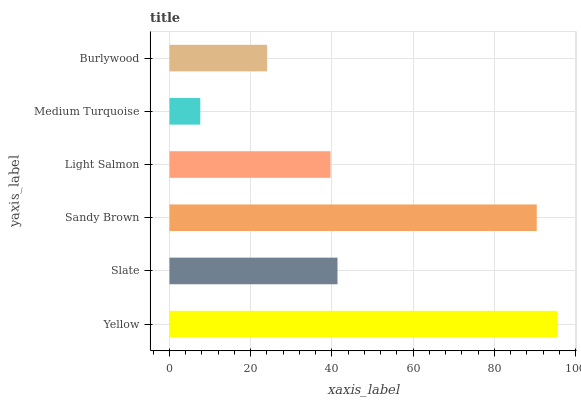Is Medium Turquoise the minimum?
Answer yes or no. Yes. Is Yellow the maximum?
Answer yes or no. Yes. Is Slate the minimum?
Answer yes or no. No. Is Slate the maximum?
Answer yes or no. No. Is Yellow greater than Slate?
Answer yes or no. Yes. Is Slate less than Yellow?
Answer yes or no. Yes. Is Slate greater than Yellow?
Answer yes or no. No. Is Yellow less than Slate?
Answer yes or no. No. Is Slate the high median?
Answer yes or no. Yes. Is Light Salmon the low median?
Answer yes or no. Yes. Is Light Salmon the high median?
Answer yes or no. No. Is Burlywood the low median?
Answer yes or no. No. 